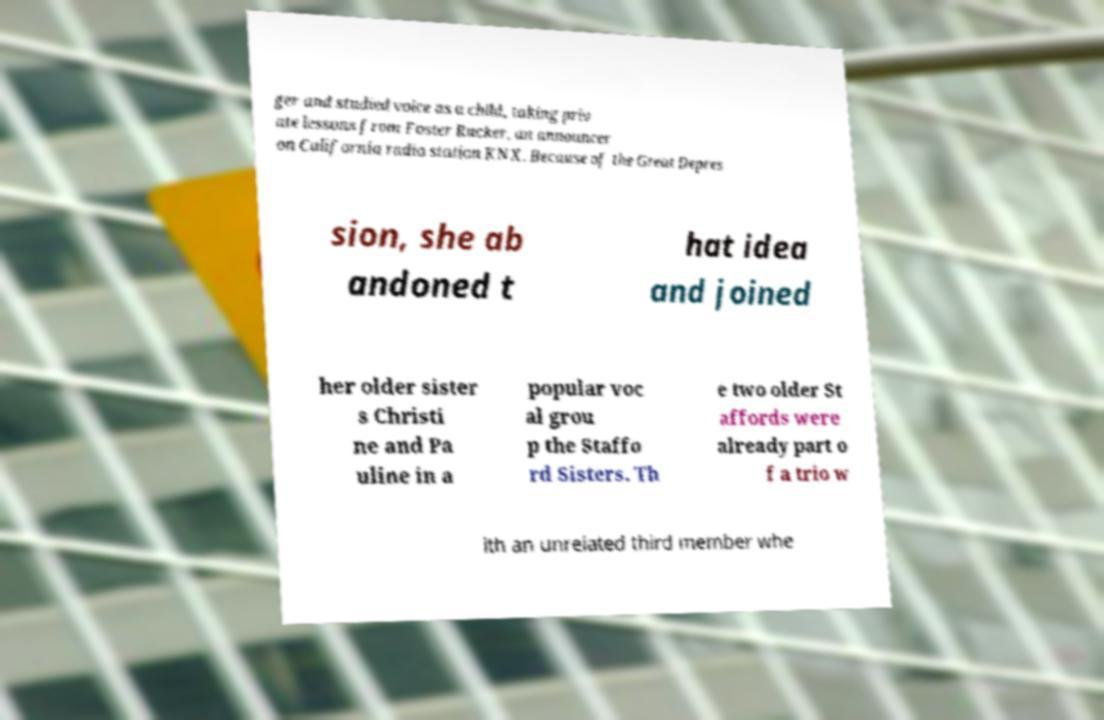Can you read and provide the text displayed in the image?This photo seems to have some interesting text. Can you extract and type it out for me? ger and studied voice as a child, taking priv ate lessons from Foster Rucker, an announcer on California radio station KNX. Because of the Great Depres sion, she ab andoned t hat idea and joined her older sister s Christi ne and Pa uline in a popular voc al grou p the Staffo rd Sisters. Th e two older St affords were already part o f a trio w ith an unrelated third member whe 